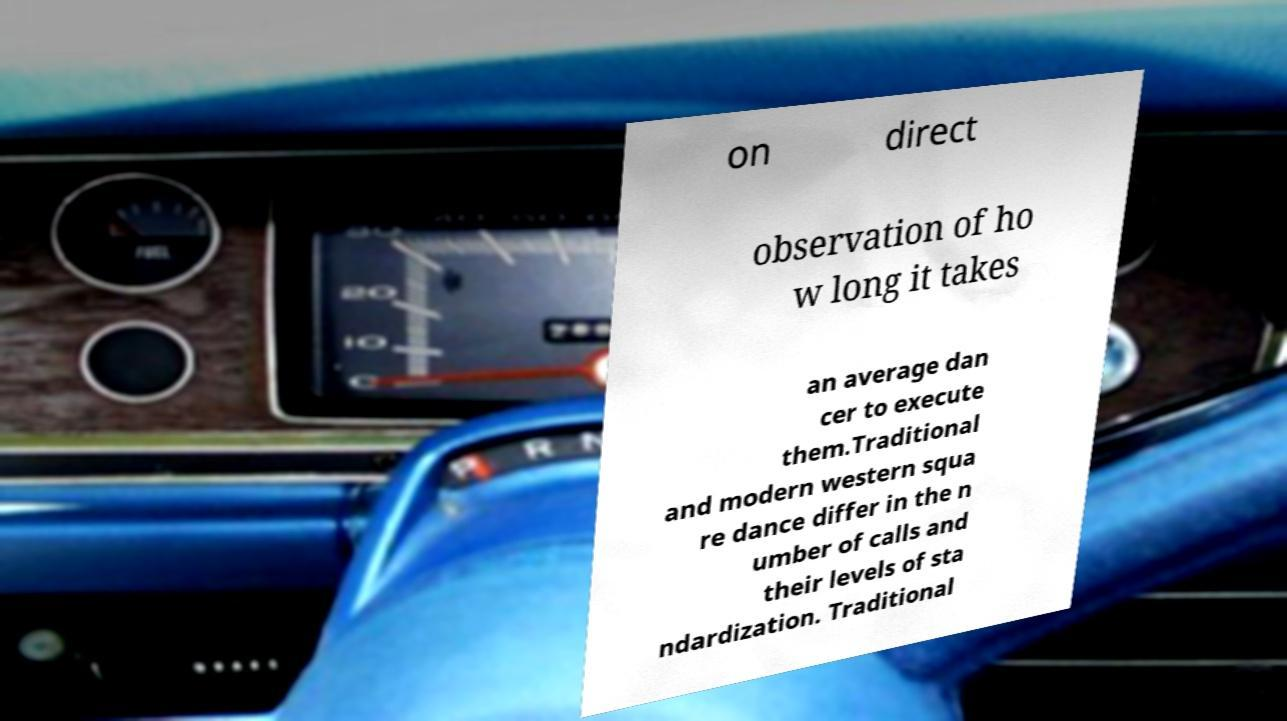What messages or text are displayed in this image? I need them in a readable, typed format. on direct observation of ho w long it takes an average dan cer to execute them.Traditional and modern western squa re dance differ in the n umber of calls and their levels of sta ndardization. Traditional 